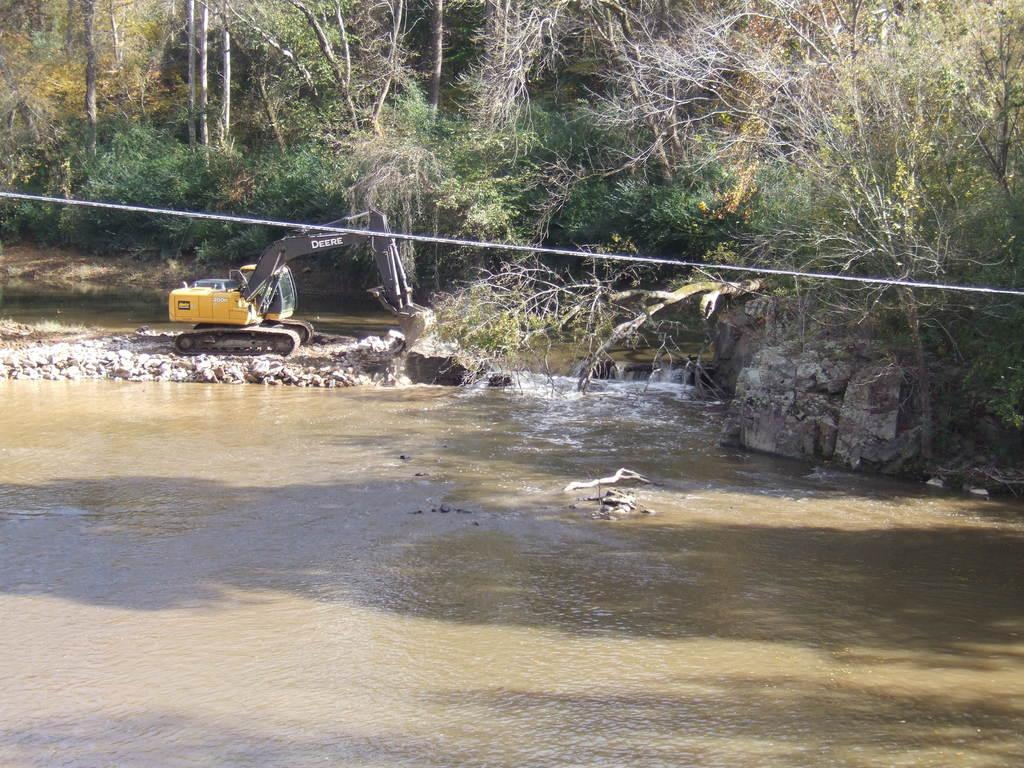What is happening in the image? Water is flowing in the image. What type of natural elements can be seen in the image? There are rocks and stones in the image. What man-made object is visible in the image? A vehicle is visible in the image. What type of vegetation is present at the top of the image? There are trees at the top of the image. What is the purpose of the rope at the top of the image? There is a rope at the top of the image, but its purpose cannot be determined from the image alone. What degree of difficulty is the wrench being used at in the image? There is no wrench present in the image, so it is not possible to determine the degree of difficulty it might be used at. 